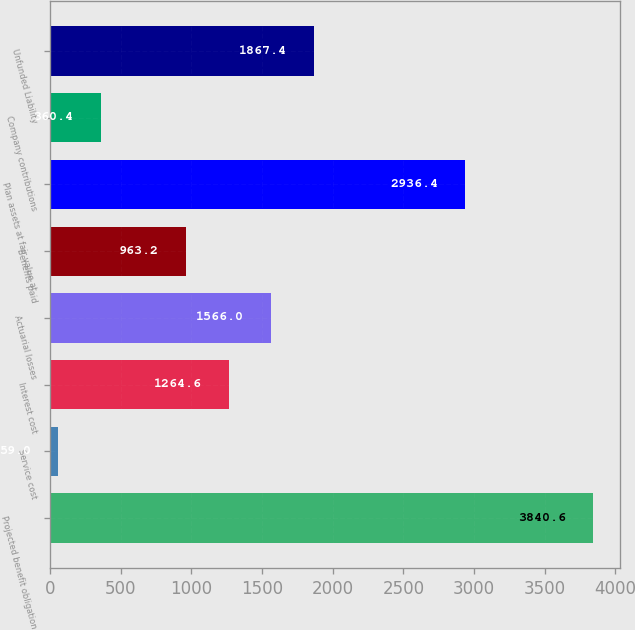<chart> <loc_0><loc_0><loc_500><loc_500><bar_chart><fcel>Projected benefit obligation<fcel>Service cost<fcel>Interest cost<fcel>Actuarial losses<fcel>Benefits paid<fcel>Plan assets at fair value at<fcel>Company contributions<fcel>Unfunded Liability<nl><fcel>3840.6<fcel>59<fcel>1264.6<fcel>1566<fcel>963.2<fcel>2936.4<fcel>360.4<fcel>1867.4<nl></chart> 